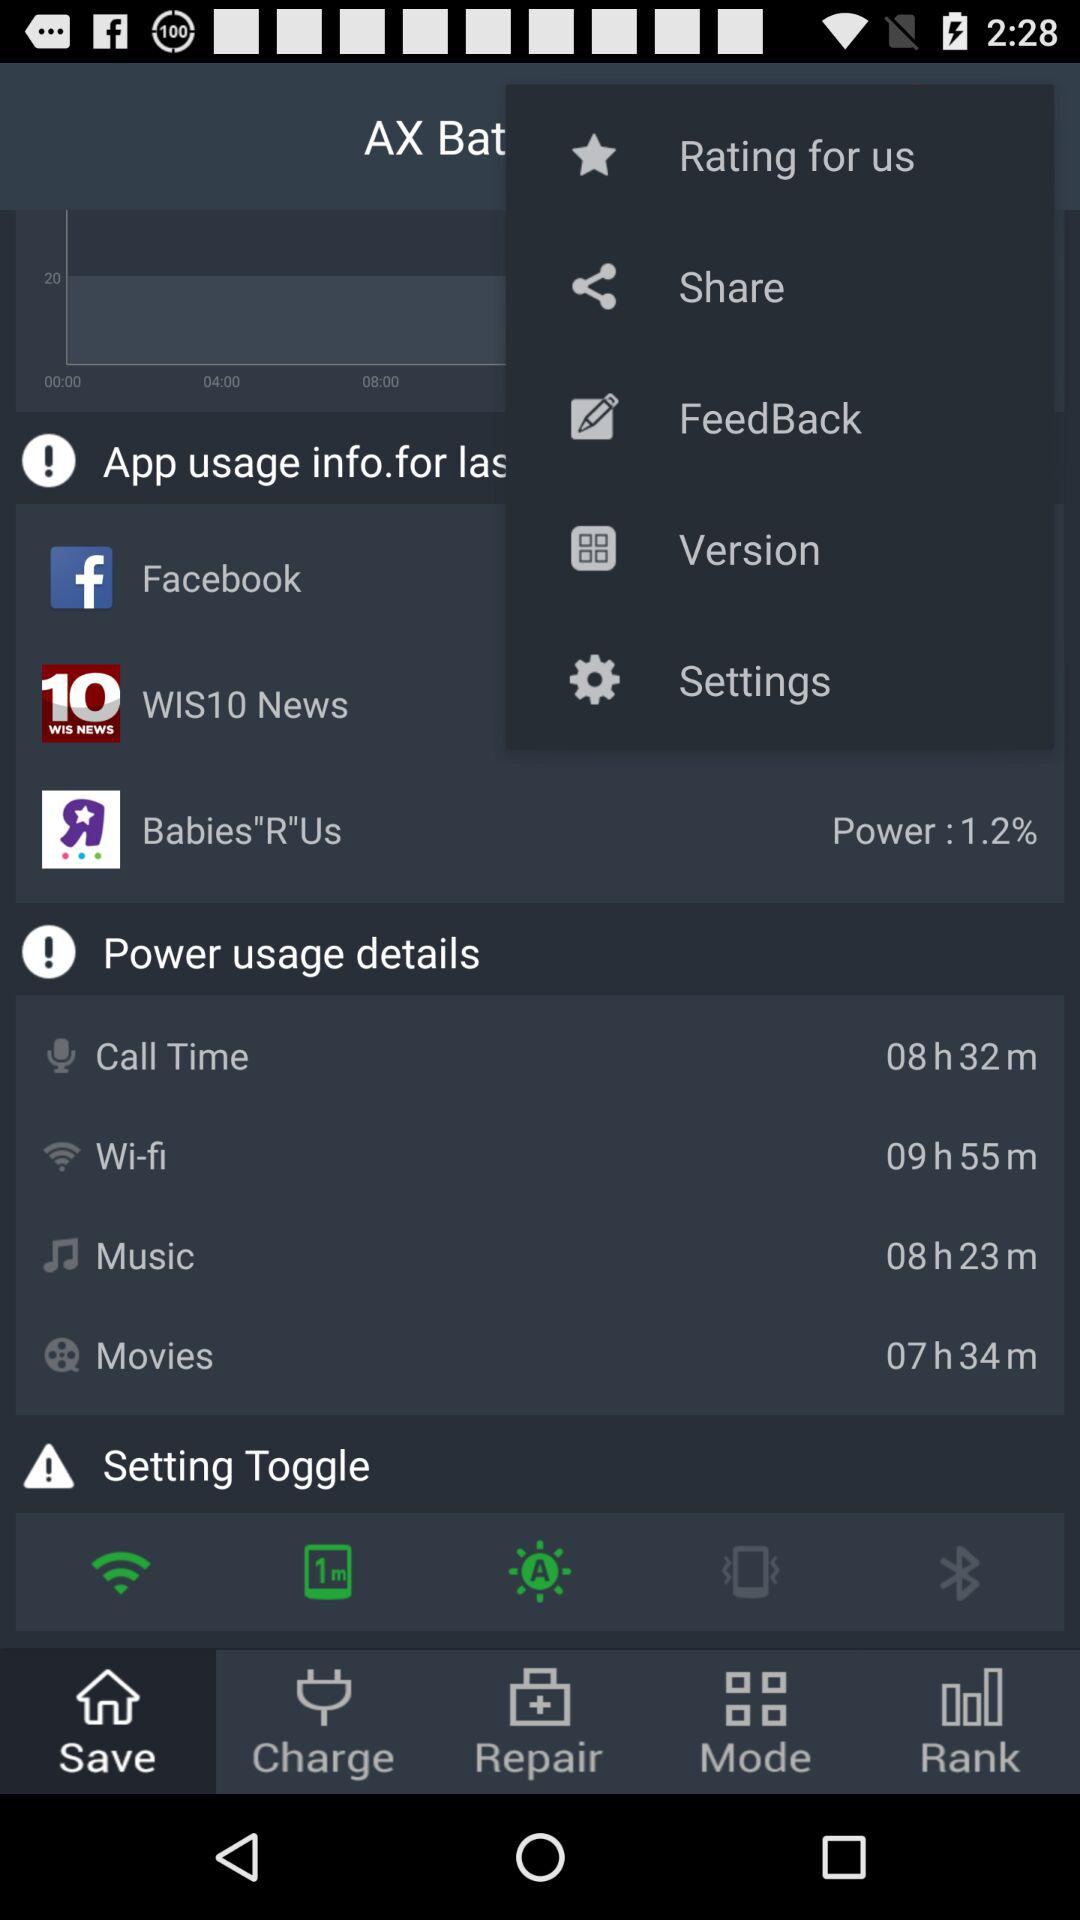Which tab is selected? The selected tab is "Save". 